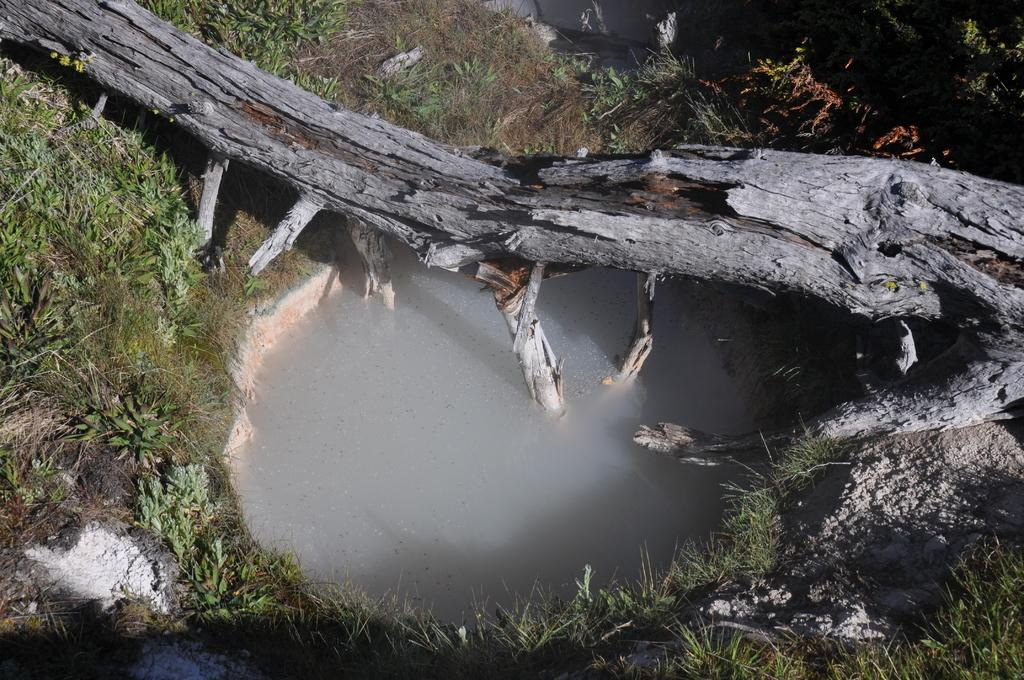What is the main object on the ground in the image? There is a dry tree trunk on the ground. What is the secondary feature visible in the image? There is a small water pond visible in the image. What type of vegetation is present on the ground? Grass is present on the ground. How many gallons of fuel can be seen in the image? There is no fuel present in the image. What type of fog is visible in the image? There is no fog present in the image. 